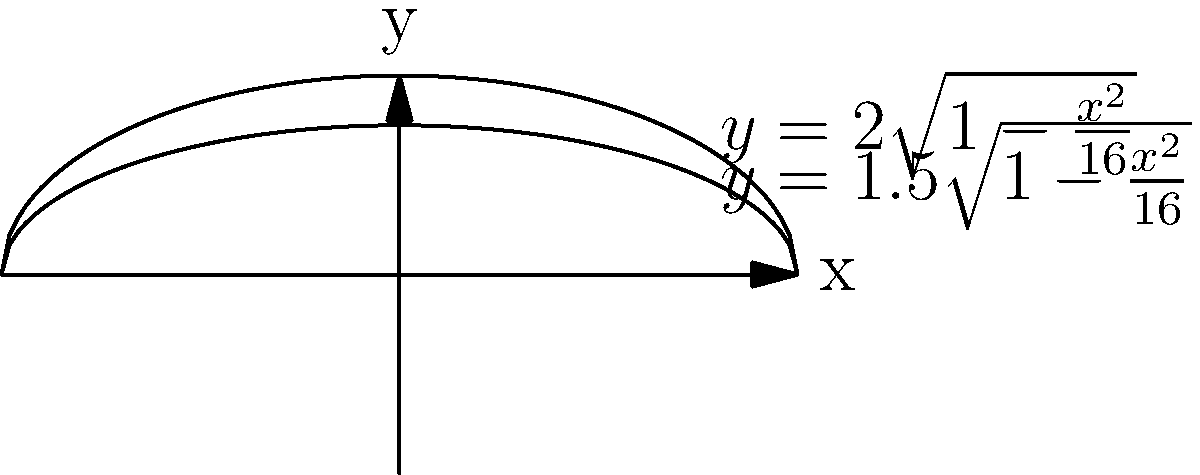A Celtic torc is modeled by rotating the region bounded by the curves $y=2\sqrt{1-\frac{x^2}{16}}$ and $y=1.5\sqrt{1-\frac{x^2}{16}}$ about the x-axis. Using the washer method, find the volume of this Celtic torc. To find the volume using the washer method, we follow these steps:

1) The washer method formula is:
   $$V = \pi \int_a^b [R(x)^2 - r(x)^2] dx$$
   where $R(x)$ is the outer function and $r(x)$ is the inner function.

2) In this case:
   $R(x) = 2\sqrt{1-\frac{x^2}{16}}$
   $r(x) = 1.5\sqrt{1-\frac{x^2}{16}}$

3) The limits of integration are from $x=-4$ to $x=4$, as these are the x-intercepts of the curves.

4) Substituting into the formula:
   $$V = \pi \int_{-4}^4 [(2\sqrt{1-\frac{x^2}{16}})^2 - (1.5\sqrt{1-\frac{x^2}{16}})^2] dx$$

5) Simplify inside the integral:
   $$V = \pi \int_{-4}^4 [4(1-\frac{x^2}{16}) - 2.25(1-\frac{x^2}{16})] dx$$
   $$V = \pi \int_{-4}^4 [1.75(1-\frac{x^2}{16})] dx$$
   $$V = 1.75\pi \int_{-4}^4 (1-\frac{x^2}{16}) dx$$

6) Integrate:
   $$V = 1.75\pi [x - \frac{x^3}{48}]_{-4}^4$$

7) Evaluate the limits:
   $$V = 1.75\pi [(4 - \frac{64}{48}) - (-4 - \frac{-64}{48})]$$
   $$V = 1.75\pi [4 - \frac{4}{3} + 4 + \frac{4}{3}]$$
   $$V = 1.75\pi [8] = 14\pi$$

Therefore, the volume of the Celtic torc is $14\pi$ cubic units.
Answer: $14\pi$ cubic units 